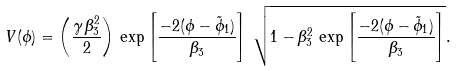Convert formula to latex. <formula><loc_0><loc_0><loc_500><loc_500>V ( \phi ) = \left ( \frac { \gamma \, \beta _ { 3 } ^ { 2 } } { 2 } \right ) \, \exp \left [ \frac { - 2 ( \phi - \tilde { \phi } _ { 1 } ) } { \beta _ { 3 } } \right ] \, \sqrt { 1 - \beta _ { 3 } ^ { 2 } \, \exp \left [ \frac { - 2 ( \phi - \tilde { \phi } _ { 1 } ) } { \beta _ { 3 } } \right ] } .</formula> 